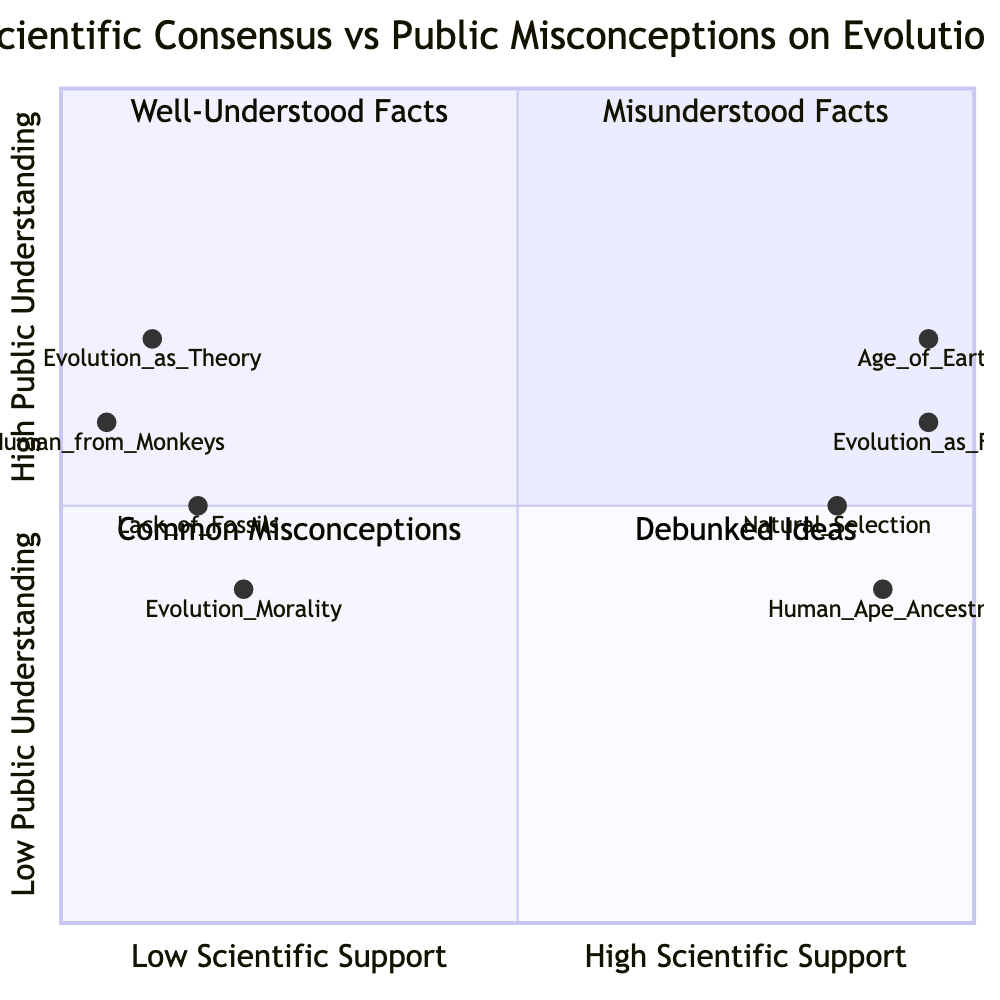What is the position of "Evolution as a Fact"? "Evolution as a Fact" is located at coordinates [0.95, 0.6], which indicates it has high scientific support (near 1 on the x-axis) and moderate public understanding (at 0.6 on the y-axis).
Answer: [0.95, 0.6] Which misconception has the lowest public understanding? "Human from Monkeys" is positioned at [0.05, 0.6], showing it has low scientific support (0.05) and moderate public understanding (0.6), making it the misconception with the lowest public understanding in the context of the diagram.
Answer: Human from Monkeys How many total nodes are in the diagram? There are a total of 8 nodes in the diagram: 4 representing scientific consensus and 4 representing public misconceptions, resulting in 8 overall nodes.
Answer: 8 What misconception lies in quadrant 3? The misconception "Lack of Transitional Fossils" falls in quadrant 3, indicating it is a common misconception with low scientific support and moderate public understanding.
Answer: Lack of Transitional Fossils Which topic shows the highest public understanding? "Age of Earth" has the highest public understanding at 0.7, situated in quadrant 2, indicating both high scientific support and understanding among the public.
Answer: Age of Earth Which two items have the same level of public understanding? "Human and Ape Ancestry" (0.4) and "Evolution and Morality" (0.4) both share the same level of public understanding on the y-axis, indicating similar public misconceptions regarding these topics.
Answer: Human and Ape Ancestry, Evolution and Morality What is the highest scientific support score? The highest scientific support score is 0.95, which is shared by "Evolution as a Fact" and "Age of Earth," positioning these topics strongly in favor of scientific consensus.
Answer: 0.95 Which topic is in quadrant 4? "Evolution as a Theory" is placed in quadrant 4, corresponding to debunked ideas, which reflects a significant misunderstanding of the concept of a scientific theory.
Answer: Evolution as a Theory 